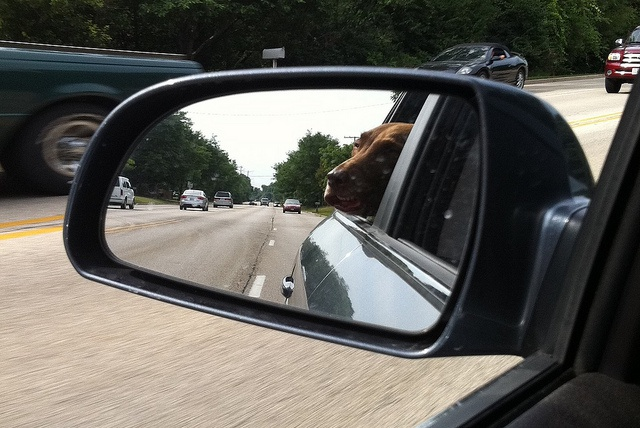Describe the objects in this image and their specific colors. I can see car in black, white, darkgray, and gray tones, truck in black, blue, gray, and darkblue tones, dog in black, gray, and maroon tones, car in black, gray, darkgray, and purple tones, and car in black, white, maroon, and gray tones in this image. 